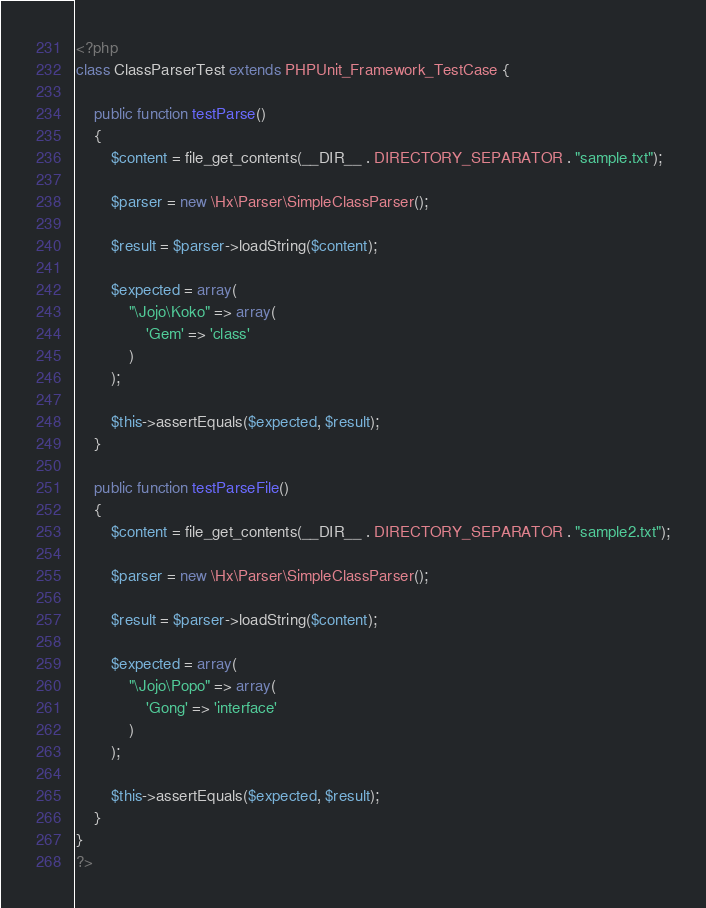Convert code to text. <code><loc_0><loc_0><loc_500><loc_500><_PHP_><?php 
class ClassParserTest extends PHPUnit_Framework_TestCase {
	
	public function testParse()
	{
		$content = file_get_contents(__DIR__ . DIRECTORY_SEPARATOR . "sample.txt");
		
		$parser = new \Hx\Parser\SimpleClassParser();
		
		$result = $parser->loadString($content);
		
		$expected = array(
			"\Jojo\Koko" => array(
				'Gem' => 'class'
			)
		);
		
		$this->assertEquals($expected, $result);
	}
	
	public function testParseFile()
	{
		$content = file_get_contents(__DIR__ . DIRECTORY_SEPARATOR . "sample2.txt");
	
		$parser = new \Hx\Parser\SimpleClassParser();
	
		$result = $parser->loadString($content);
	
		$expected = array(
			"\Jojo\Popo" => array(
				'Gong' => 'interface'
			)
		);
	
		$this->assertEquals($expected, $result);
	}
}
?></code> 